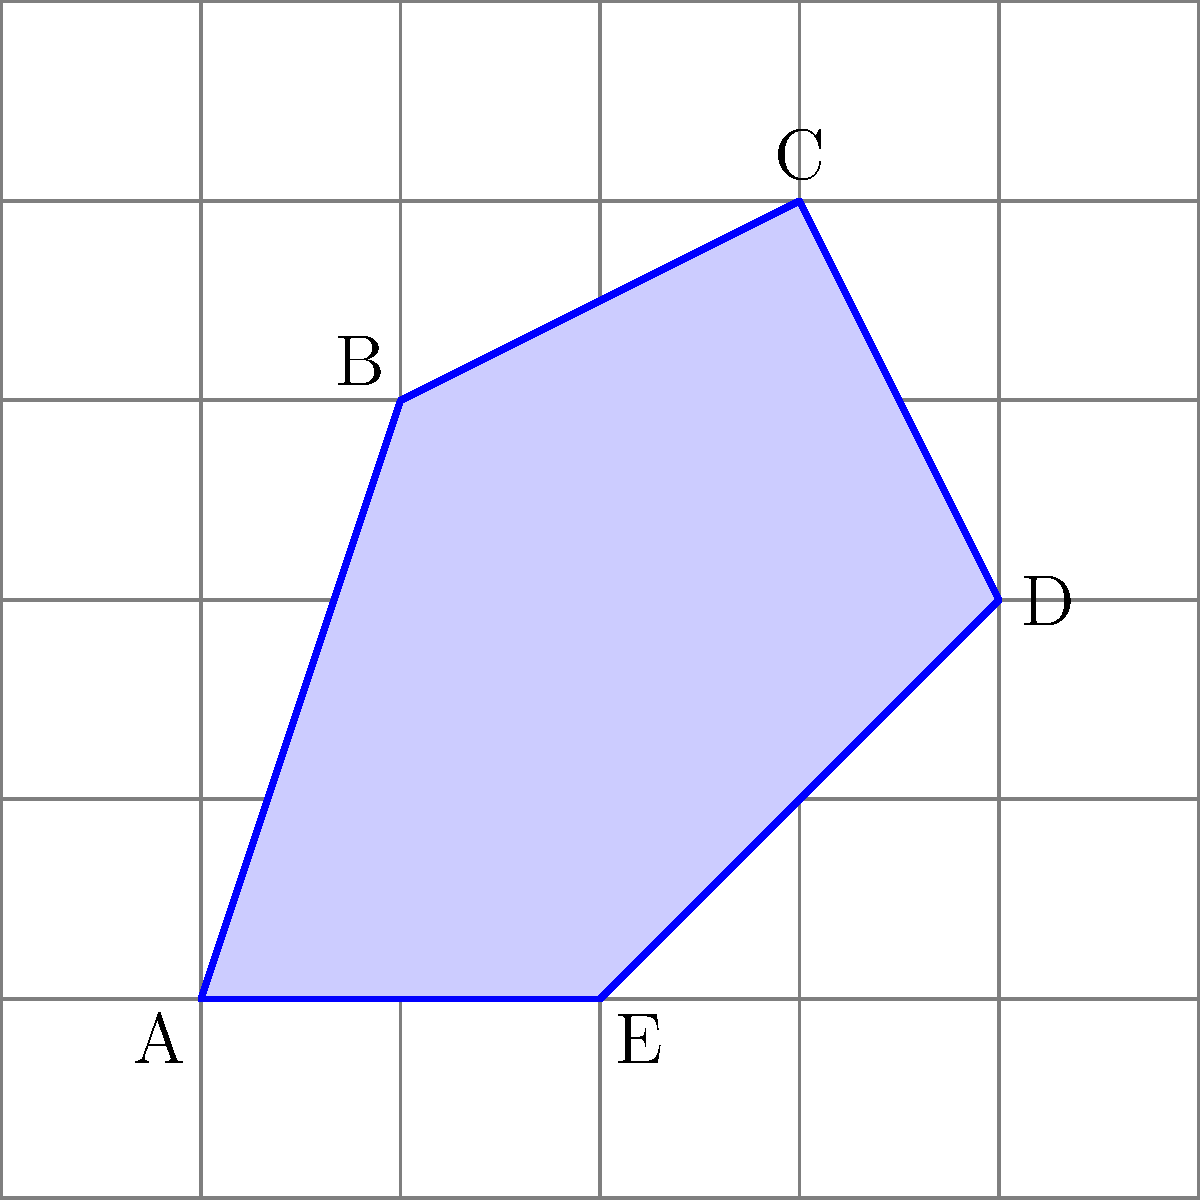In the grid system shown above, where each square represents 1 unit$^2$, estimate the area of the irregular polygon ABCDE using the counting squares method. Round your answer to the nearest whole number. To estimate the area of the irregular polygon using the counting squares method, we'll follow these steps:

1. Count the number of whole squares inside the polygon.
2. Count the number of partial squares that are more than half filled.
3. Count the number of partial squares that are less than half filled.
4. Add the whole squares and more-than-half squares.
5. Add 0.5 for each less-than-half square.

Let's go through this process:

1. Whole squares: There are approximately 9 whole squares inside the polygon.

2. More-than-half squares: There are about 6 squares that are more than half filled.

3. Less-than-half squares: There are about 4 squares that are less than half filled.

4. Adding whole and more-than-half squares: 9 + 6 = 15

5. Adding for less-than-half squares: 15 + (4 * 0.5) = 17

Therefore, our estimate for the area is 17 square units.

Rounding to the nearest whole number: 17 square units.

This method provides a reasonable approximation of the area without requiring complex calculations, which aligns with the grid-based approach often used in JavaScript for layout and positioning in web development.
Answer: 17 square units 